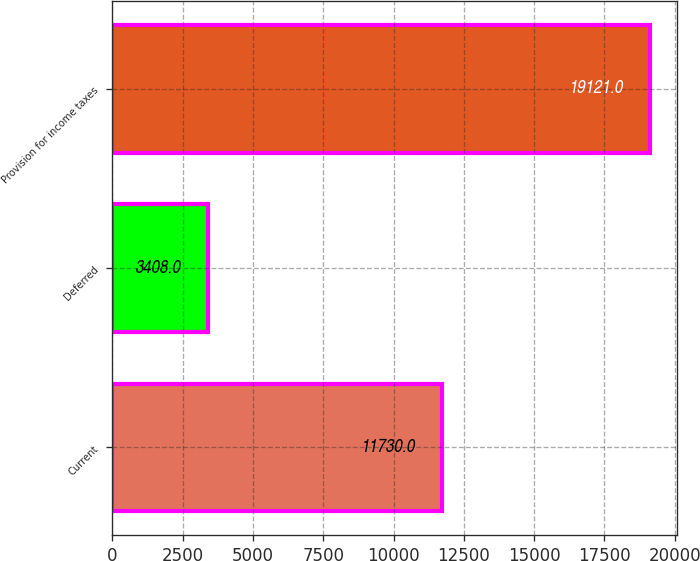<chart> <loc_0><loc_0><loc_500><loc_500><bar_chart><fcel>Current<fcel>Deferred<fcel>Provision for income taxes<nl><fcel>11730<fcel>3408<fcel>19121<nl></chart> 